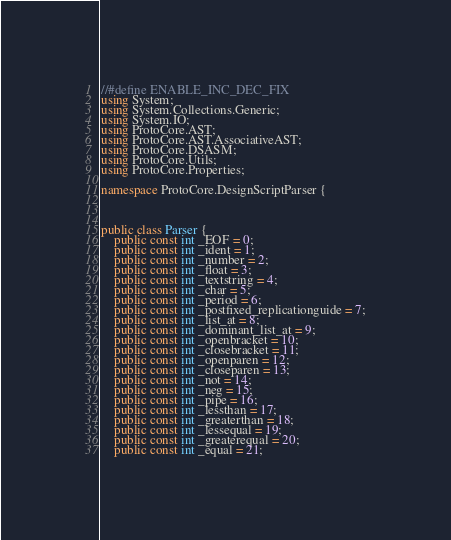Convert code to text. <code><loc_0><loc_0><loc_500><loc_500><_C#_>
//#define ENABLE_INC_DEC_FIX
using System;
using System.Collections.Generic;
using System.IO;
using ProtoCore.AST;
using ProtoCore.AST.AssociativeAST;
using ProtoCore.DSASM;
using ProtoCore.Utils;
using ProtoCore.Properties;

namespace ProtoCore.DesignScriptParser {



public class Parser {
	public const int _EOF = 0;
	public const int _ident = 1;
	public const int _number = 2;
	public const int _float = 3;
	public const int _textstring = 4;
	public const int _char = 5;
	public const int _period = 6;
	public const int _postfixed_replicationguide = 7;
	public const int _list_at = 8;
	public const int _dominant_list_at = 9;
	public const int _openbracket = 10;
	public const int _closebracket = 11;
	public const int _openparen = 12;
	public const int _closeparen = 13;
	public const int _not = 14;
	public const int _neg = 15;
	public const int _pipe = 16;
	public const int _lessthan = 17;
	public const int _greaterthan = 18;
	public const int _lessequal = 19;
	public const int _greaterequal = 20;
	public const int _equal = 21;</code> 